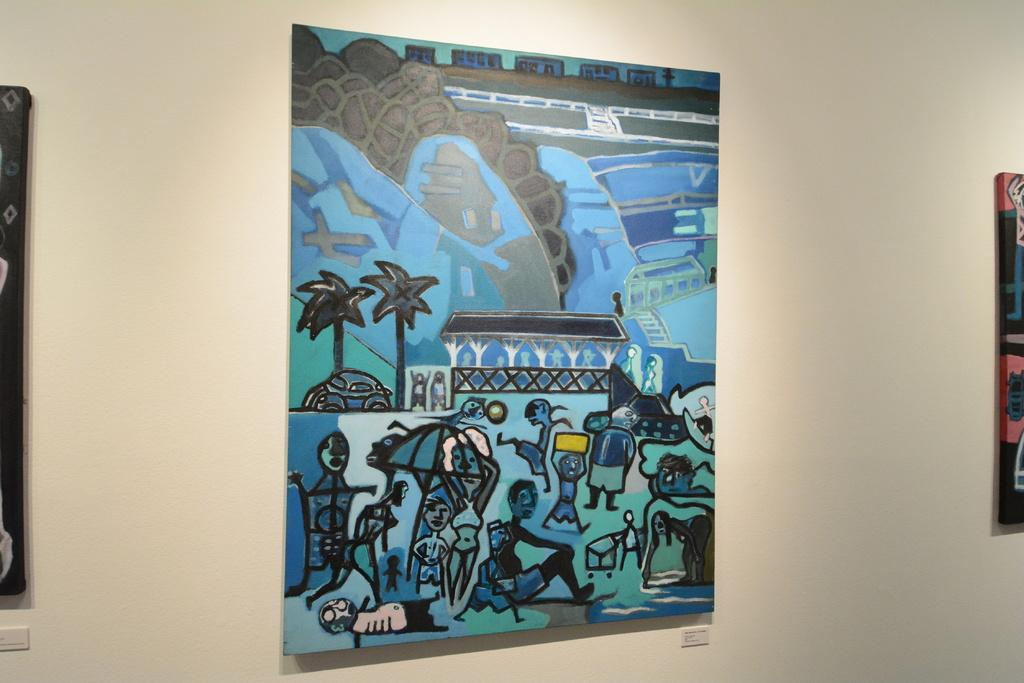What is located in the center of the image? There is a poster in the center of the image. What type of pen can be seen in the image? There is no pen present in the image; it only features a poster in the center. What color is the arch in the image? There is no arch present in the image. What type of fruit is visible on the poster in the image? The provided facts do not mention any fruit, including oranges, on the poster or in the image. 